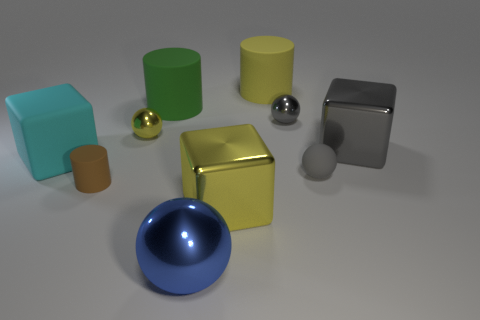What number of yellow metal things are on the right side of the yellow shiny thing that is behind the big cyan rubber thing?
Give a very brief answer. 1. What number of other objects are the same shape as the big green rubber thing?
Your answer should be compact. 2. What material is the cube that is the same color as the rubber sphere?
Provide a succinct answer. Metal. How many shiny spheres are the same color as the rubber sphere?
Keep it short and to the point. 1. What color is the cube that is the same material as the tiny cylinder?
Your answer should be very brief. Cyan. Is there a brown object of the same size as the gray matte object?
Your answer should be compact. Yes. Is the number of big cylinders that are in front of the gray matte sphere greater than the number of tiny gray shiny things on the left side of the large metal ball?
Provide a short and direct response. No. Do the tiny gray object that is behind the matte ball and the big block that is to the right of the gray matte ball have the same material?
Offer a terse response. Yes. What shape is the blue thing that is the same size as the gray cube?
Ensure brevity in your answer.  Sphere. Is there a green rubber object that has the same shape as the yellow matte thing?
Your answer should be very brief. Yes. 